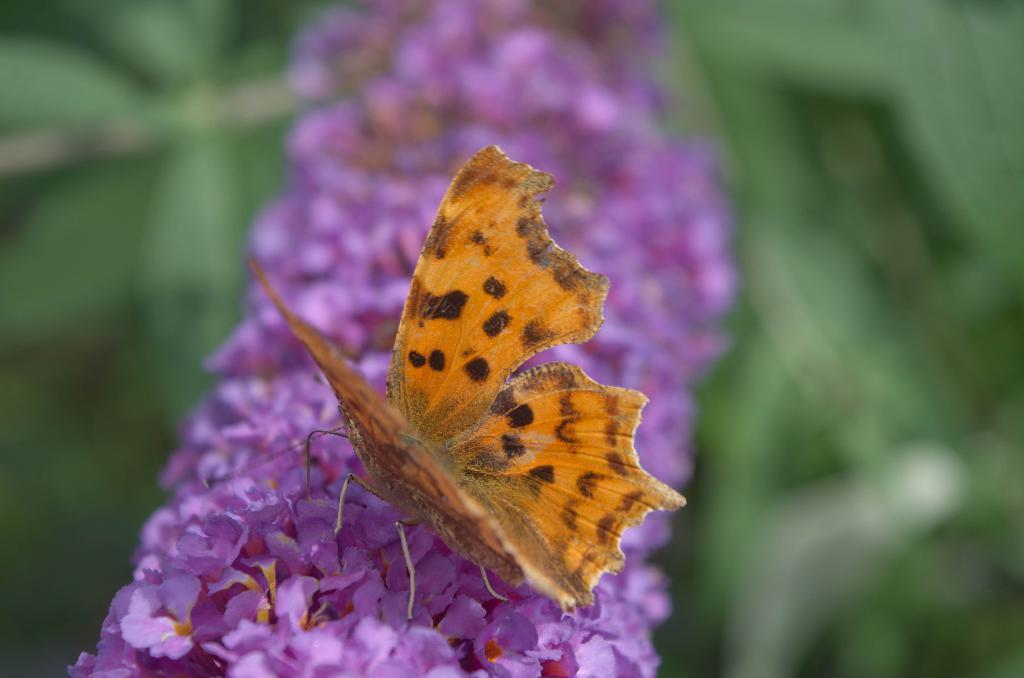Can you describe this image briefly? In the center of this picture we can see a butterfly on the flowers. The background of the image is blurry and we can see the green color objects seems to be the leaves in the background. 